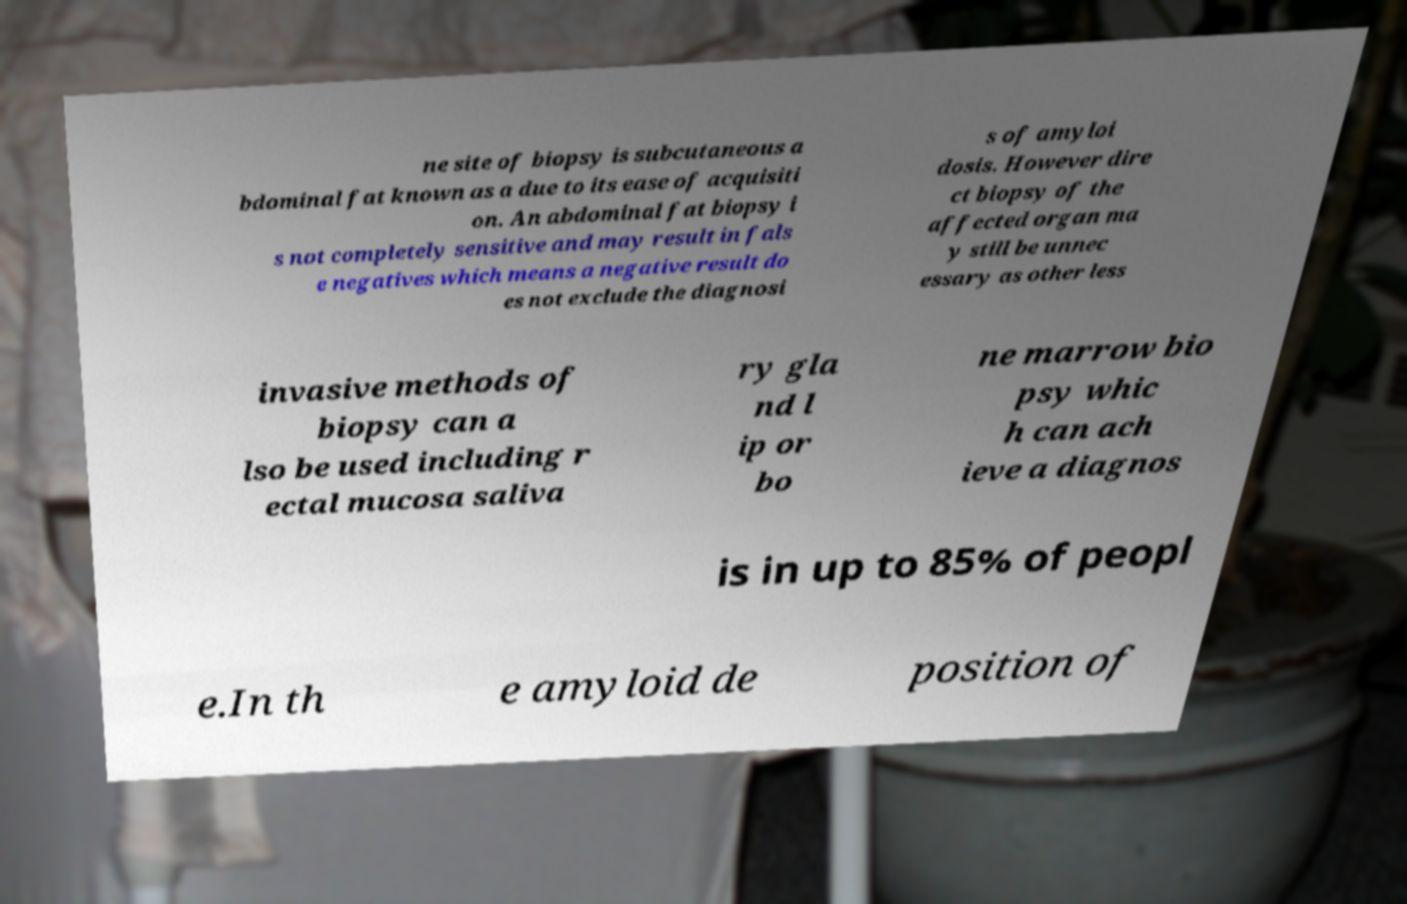Can you read and provide the text displayed in the image?This photo seems to have some interesting text. Can you extract and type it out for me? ne site of biopsy is subcutaneous a bdominal fat known as a due to its ease of acquisiti on. An abdominal fat biopsy i s not completely sensitive and may result in fals e negatives which means a negative result do es not exclude the diagnosi s of amyloi dosis. However dire ct biopsy of the affected organ ma y still be unnec essary as other less invasive methods of biopsy can a lso be used including r ectal mucosa saliva ry gla nd l ip or bo ne marrow bio psy whic h can ach ieve a diagnos is in up to 85% of peopl e.In th e amyloid de position of 